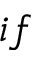Convert formula to latex. <formula><loc_0><loc_0><loc_500><loc_500>i f</formula> 